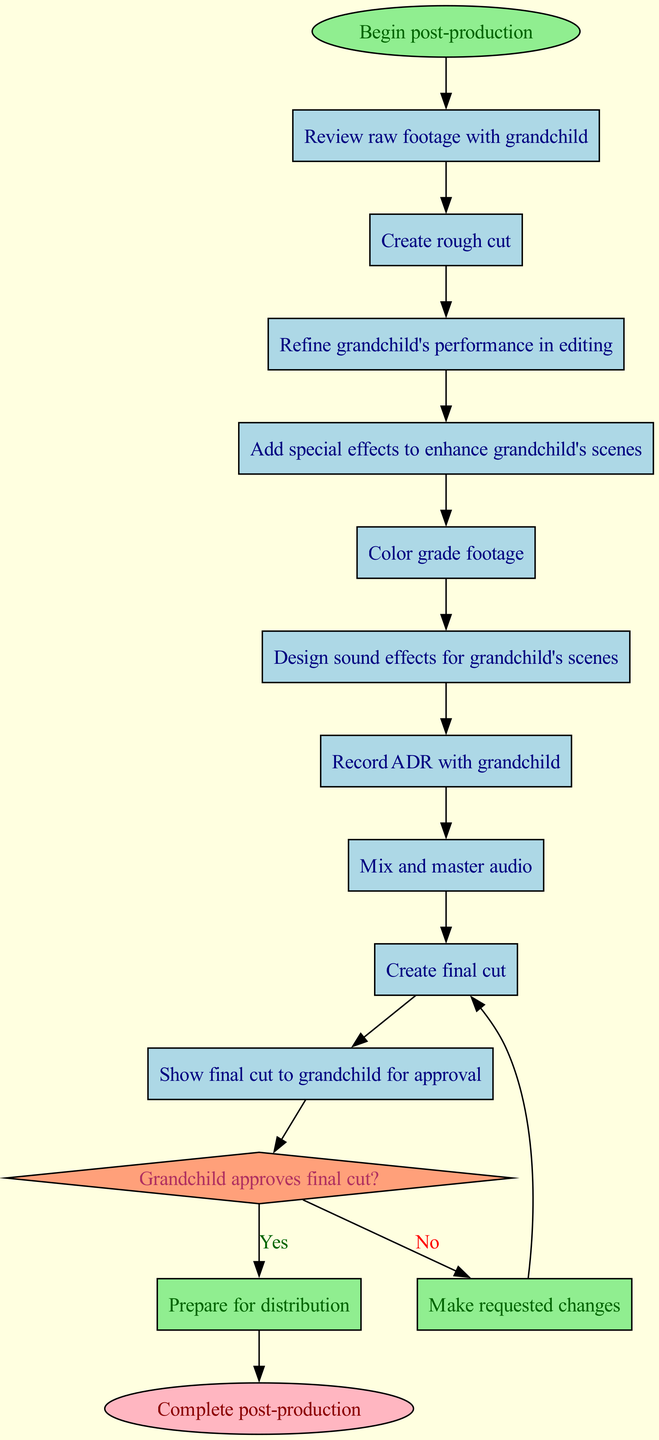What is the first activity in the post-production workflow? The first activity listed in the diagram is "Review raw footage with grandchild." This is directly identified as the first node following the start node.
Answer: Review raw footage with grandchild How many activities are there in the diagram? The diagram contains a total of 10 activities, which are listed in sequence. This can be counted directly from the list of activities in the diagram.
Answer: 10 What happens if the grandchild does not approve the final cut? If the grandchild does not approve the final cut, the workflow directs to "Make requested changes." This is the output connected to the decision node upon a "No" response.
Answer: Make requested changes What is the last activity before the decision point in the workflow? The last activity before the decision point is "Show final cut to grandchild for approval." This can be found as the activity directly connected to the decision node.
Answer: Show final cut to grandchild for approval What color represents the start node in the diagram? The start node is represented in light green color according to the coloring scheme used in the diagram. It is specifically noted in the attributes given for the start node.
Answer: Light green How many decision points are present in the diagram? There is only 1 decision point present in the diagram, which is related to the approval of the final cut by the grandchild. This can be confirmed by observing the decision node section.
Answer: 1 What activity follows after the grandchild approves the final cut? After the grandchild approves the final cut, the workflow moves to "Prepare for distribution." This is the direct outcome connected to the "Yes" branch of the decision node.
Answer: Prepare for distribution Which activity involves the grandchild directly, apart from the review process? Apart from the review process, the activity "Record ADR with grandchild" also involves the grandchild directly, as the grandchild is specifically mentioned with this activity.
Answer: Record ADR with grandchild What is the final node labeled in the workflow? The final node in the workflow is labeled "Complete post-production." This can be seen connected from the "Yes" outcome of the decision node.
Answer: Complete post-production 